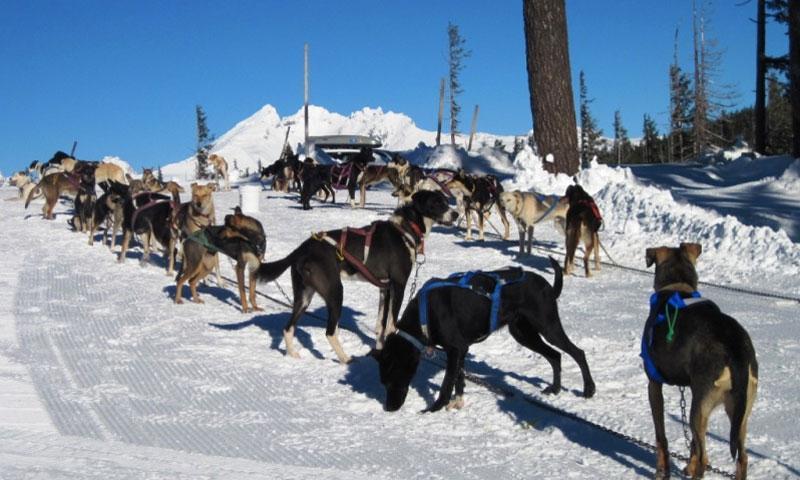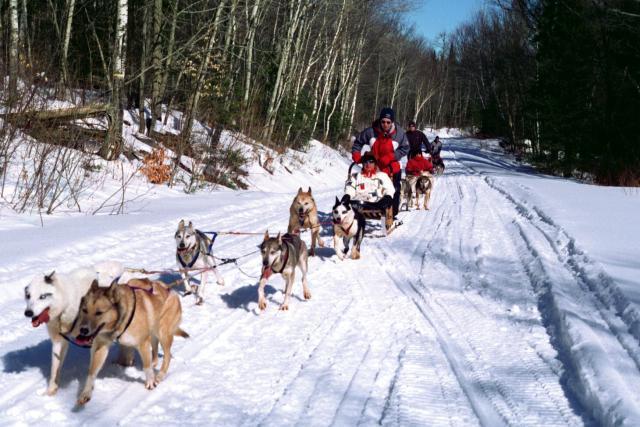The first image is the image on the left, the second image is the image on the right. Assess this claim about the two images: "There is at least one person wearing a red coat in the image on the right.". Correct or not? Answer yes or no. Yes. 